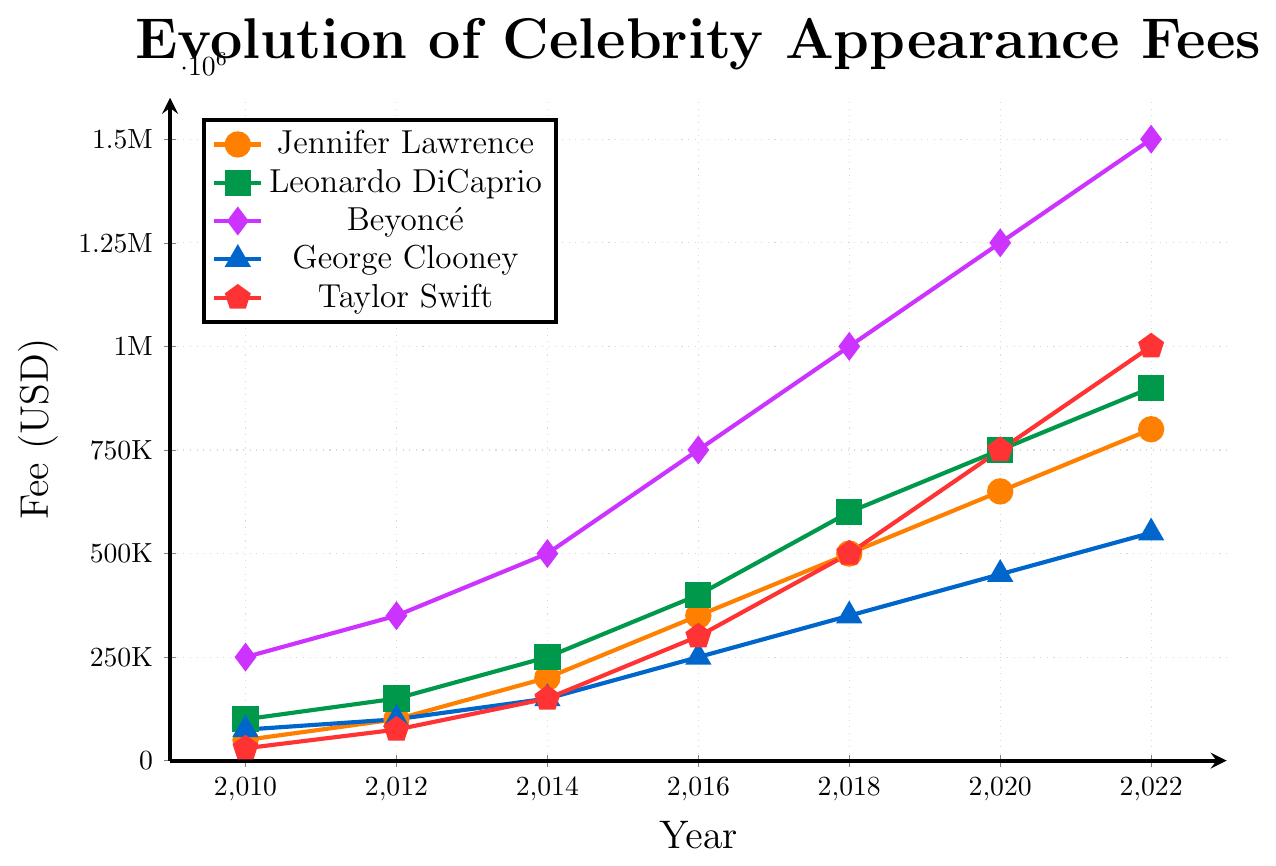What is the appearance fee trend for Jennifer Lawrence from 2010 to 2022? Start by identifying the fees for Jennifer Lawrence in each year: 2010 ($50,000), 2012 ($100,000), 2014 ($200,000), 2016 ($350,000), 2018 ($500,000), 2020 ($650,000), and 2022 ($800,000). The trend shows a steady increase over the years.
Answer: Steady increase Who had the highest appearance fee in 2022? By examining the highest point on the graph in 2022, Beyoncé had the highest fee of $1,500,000.
Answer: Beyoncé How much did Taylor Swift's appearance fee increase from 2010 to 2022? Taylor Swift's fee was $30,000 in 2010 and increased to $1,000,000 in 2022. The difference is $1,000,000 - $30,000 = $970,000.
Answer: $970,000 Between Leonardo DiCaprio and George Clooney, whose fee increased more from 2010 to 2022? Leonardo DiCaprio's fee increased from $100,000 in 2010 to $900,000 in 2022, an increase of $800,000. George Clooney's fee increased from $75,000 in 2010 to $550,000 in 2022, an increase of $475,000. Therefore, Leonardo DiCaprio's fee increased more.
Answer: Leonardo DiCaprio Compare the growth rates of Jennifer Lawrence and Taylor Swift from 2010 to 2022. Who had a higher growth rate and by how much? Jennifer Lawrence's fee increased from $50,000 to $800,000, a growth of $750,000. Taylor Swift's fee increased from $30,000 to $1,000,000, a growth of $970,000. Taylor Swift had a higher growth rate by $970,000 - $750,000 = $220,000.
Answer: Taylor Swift by $220,000 What is the difference in appearance fees between Beyoncé and George Clooney in 2020? Beyoncé's fee in 2020 is $1,250,000 and George Clooney's fee is $450,000. The difference is $1,250,000 - $450,000 = $800,000.
Answer: $800,000 Who had the smallest increase in appearance fee from 2018 to 2020? The increases from 2018 to 2020 are: Jennifer Lawrence ($650,000 - $500,000 = $150,000), Leonardo DiCaprio ($750,000 - $600,000 = $150,000), Beyoncé ($1,250,000 - $1,000,000 = $250,000), George Clooney ($450,000 - $350,000 = $100,000), Taylor Swift ($750,000 - $500,000 = $250,000). George Clooney had the smallest increase of $100,000.
Answer: George Clooney From 2010 to 2022, whose fee increased the fastest and how can you tell? By observing the steepest slope on the graph, Beyoncé’s fee increased from $250,000 in 2010 to $1,500,000 in 2022, marking the fastest increase.
Answer: Beyoncé 